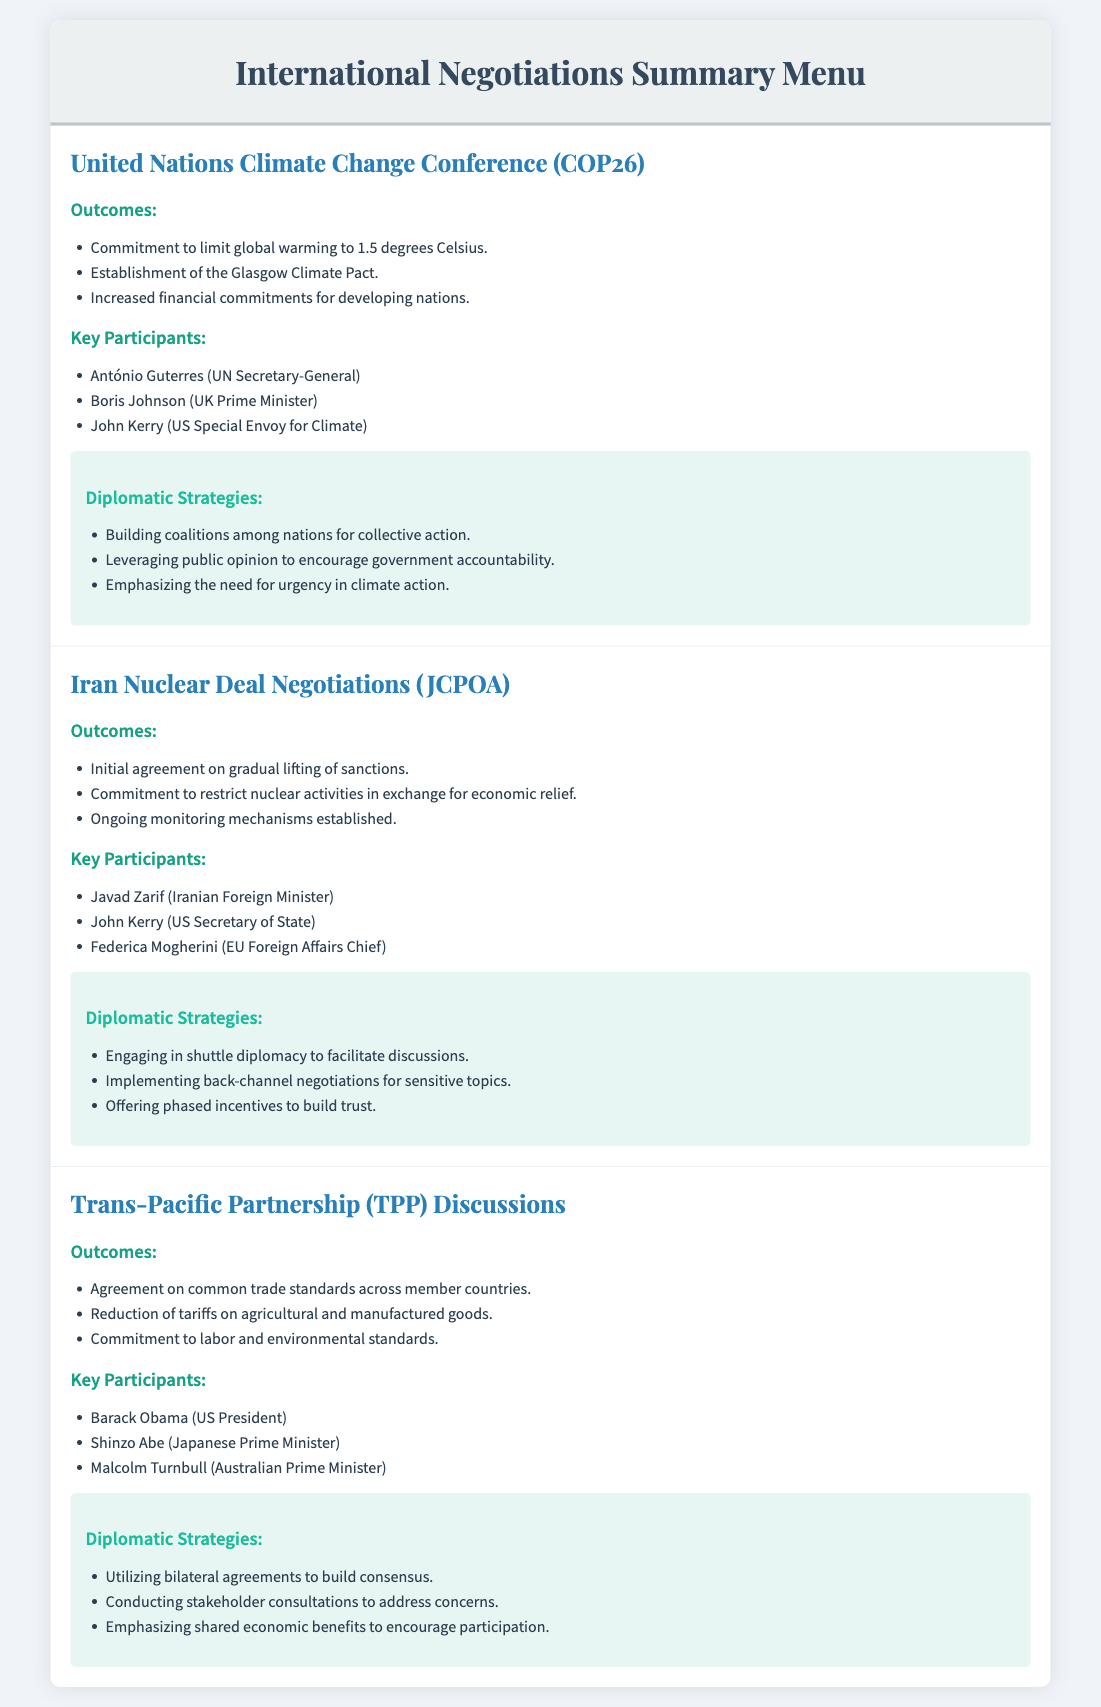what was the commitment made at COP26? The commitment made at COP26 was to limit global warming to 1.5 degrees Celsius.
Answer: limit global warming to 1.5 degrees Celsius who was the UN Secretary-General during COP26? The UN Secretary-General during COP26 was António Guterres.
Answer: António Guterres what were the key outcomes of the Iran Nuclear Deal Negotiations? The key outcomes included an initial agreement on gradual lifting of sanctions and commitment to restrict nuclear activities.
Answer: gradual lifting of sanctions which strategy was employed during the Iran Nuclear Deal Negotiations? One of the strategies employed was engaging in shuttle diplomacy to facilitate discussions.
Answer: shuttle diplomacy how many key participants are listed for the Trans-Pacific Partnership discussions? There are three key participants listed for the Trans-Pacific Partnership discussions.
Answer: three what document was established during COP26? The document established during COP26 was the Glasgow Climate Pact.
Answer: Glasgow Climate Pact what is one of the phased incentives mentioned in the Iran Nuclear Deal Negotiations? One of the incentives mentioned is offering phased incentives to build trust.
Answer: phased incentives what common agreement was reached in the TPP discussions? The common agreement reached was on trade standards across member countries.
Answer: trade standards across member countries who was the US President during the TPP discussions? The US President during the TPP discussions was Barack Obama.
Answer: Barack Obama 